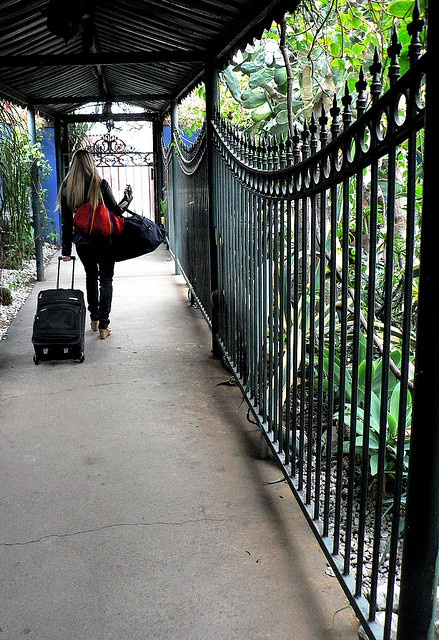Describe the objects in this image and their specific colors. I can see people in black, maroon, gray, and darkgreen tones, suitcase in black, lightgray, and gray tones, handbag in black, white, navy, and gray tones, and handbag in black, maroon, and brown tones in this image. 